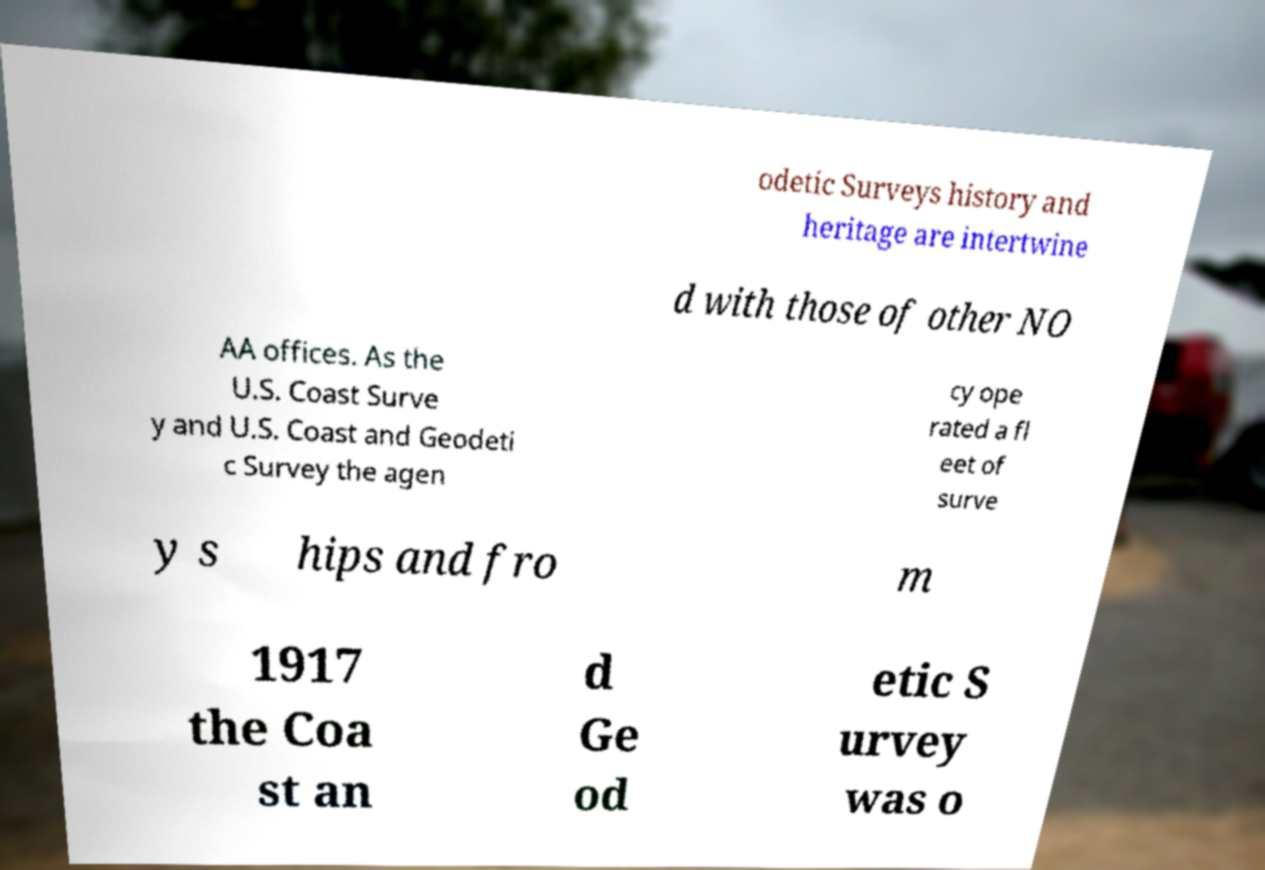Can you accurately transcribe the text from the provided image for me? odetic Surveys history and heritage are intertwine d with those of other NO AA offices. As the U.S. Coast Surve y and U.S. Coast and Geodeti c Survey the agen cy ope rated a fl eet of surve y s hips and fro m 1917 the Coa st an d Ge od etic S urvey was o 